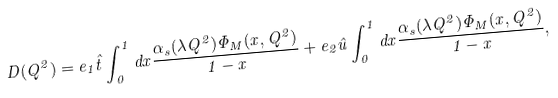<formula> <loc_0><loc_0><loc_500><loc_500>D ( Q ^ { 2 } ) = e _ { 1 } \hat { t } \int _ { 0 } ^ { 1 } d x \frac { \alpha _ { s } ( \lambda Q ^ { 2 } ) \Phi _ { M } ( x , Q ^ { 2 } ) } { 1 - x } + e _ { 2 } \hat { u } \int _ { 0 } ^ { 1 } d x \frac { \alpha _ { s } ( \lambda Q ^ { 2 } ) \Phi _ { M } ( x , Q ^ { 2 } ) } { 1 - x } ,</formula> 